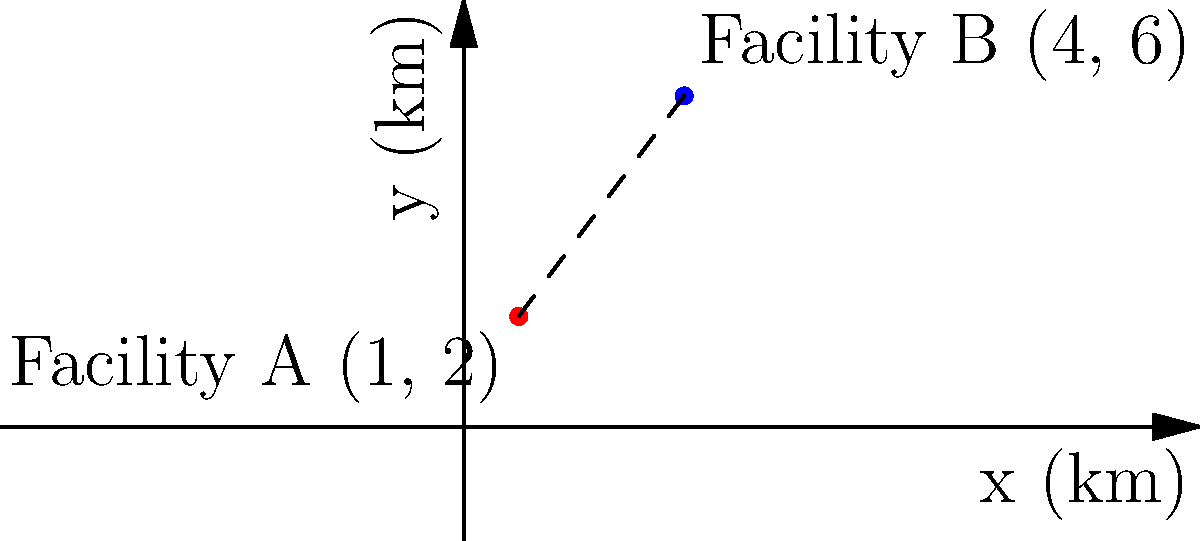Two seed storage facilities are located on a map with a coordinate system measured in kilometers. Facility A is at coordinates (1, 2) and Facility B is at coordinates (4, 6). Calculate the straight-line distance between these two facilities. To find the distance between two points on a coordinate plane, we can use the distance formula, which is derived from the Pythagorean theorem:

$$ d = \sqrt{(x_2 - x_1)^2 + (y_2 - y_1)^2} $$

Where $(x_1, y_1)$ are the coordinates of the first point and $(x_2, y_2)$ are the coordinates of the second point.

Step 1: Identify the coordinates
Facility A: $(x_1, y_1) = (1, 2)$
Facility B: $(x_2, y_2) = (4, 6)$

Step 2: Plug the values into the distance formula
$$ d = \sqrt{(4 - 1)^2 + (6 - 2)^2} $$

Step 3: Simplify the expressions inside the parentheses
$$ d = \sqrt{3^2 + 4^2} $$

Step 4: Calculate the squares
$$ d = \sqrt{9 + 16} $$

Step 5: Add the values under the square root
$$ d = \sqrt{25} $$

Step 6: Calculate the square root
$$ d = 5 $$

Therefore, the straight-line distance between Facility A and Facility B is 5 kilometers.
Answer: 5 km 